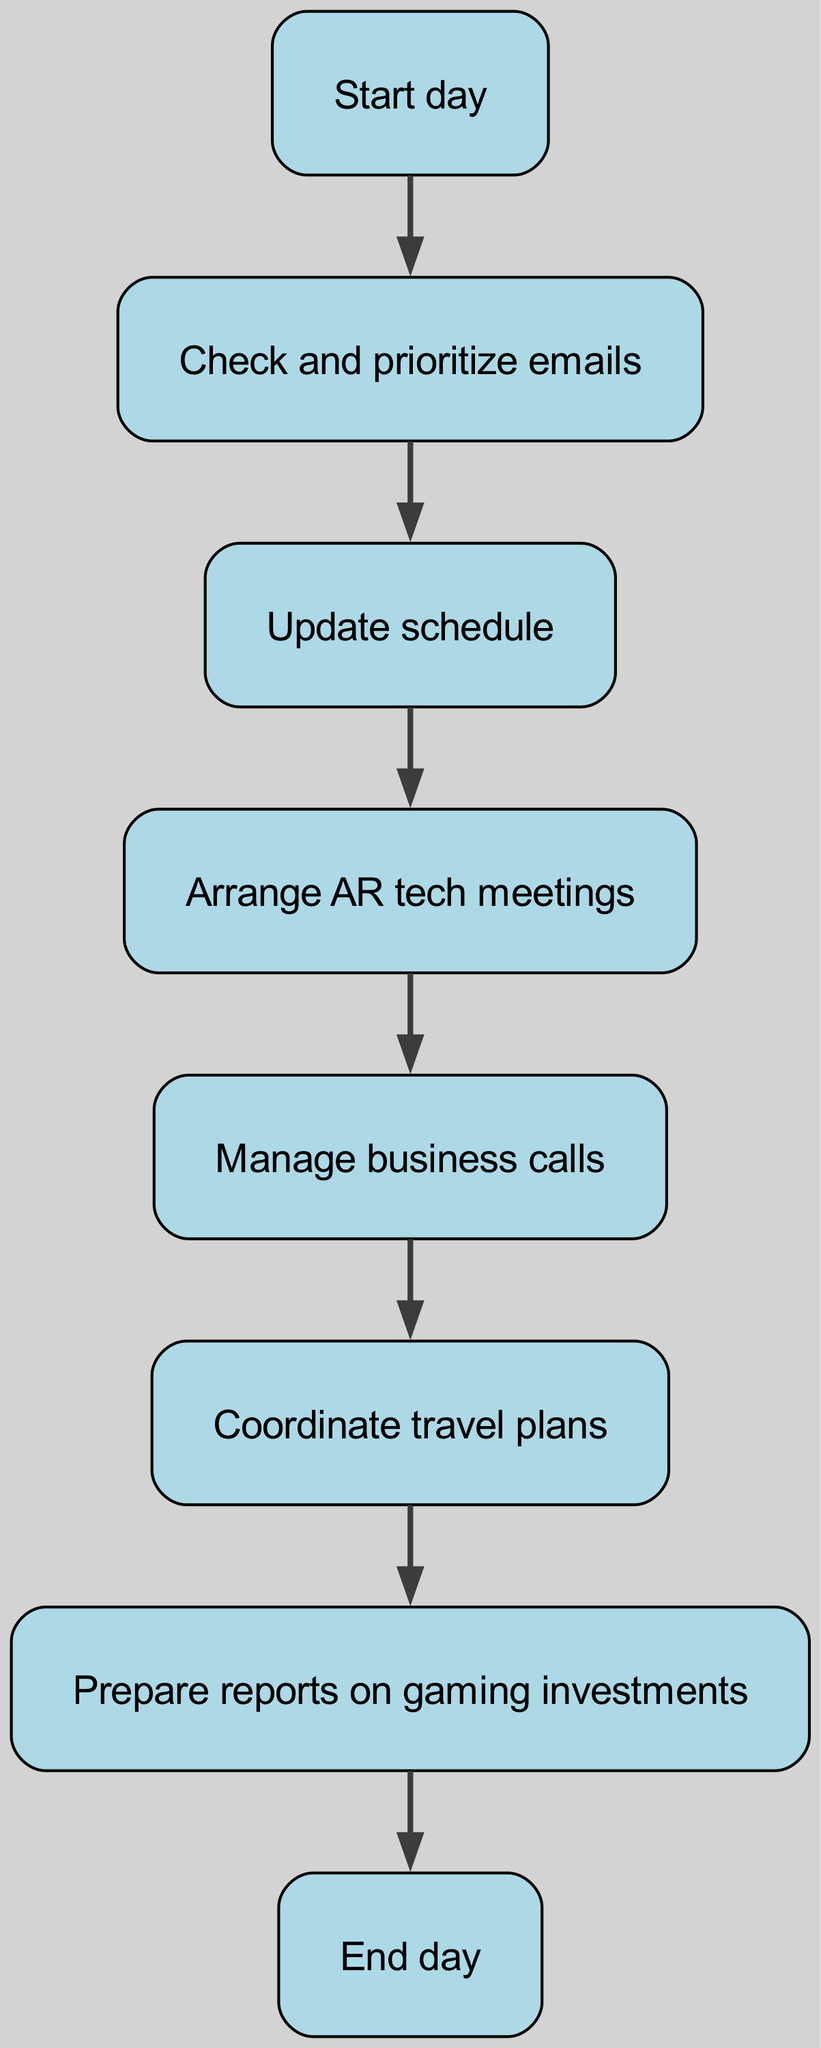What is the starting point of the workflow? The workflow begins at the node labeled "Start day." This is the first node in the diagram that indicates where the daily tasks commence.
Answer: Start day How many nodes are present in the diagram? To find the total number of nodes, we can count each unique node in the diagram. There are eight nodes labeled from "Start day" to "End day."
Answer: Eight What is the last step in the workflow? The workflow ends with the node labeled "End day," which signifies the conclusion of the daily tasks. This node is the last in the flow sequence.
Answer: End day Which task immediately follows checking and prioritizing emails? The task that comes after "Check and prioritize emails" is "Update schedule." This relationship is shown in the flow from node two to node three.
Answer: Update schedule What task is arranged after updating the schedule? After updating the schedule, the next task arranged is "Arrange AR tech meetings." This follows the sequential flow outlined in the diagram.
Answer: Arrange AR tech meetings How does the workflow progress after arranging AR tech meetings? The workflow continues from "Arrange AR tech meetings" to "Manage business calls." This transition is directly indicated in the flow of the diagram.
Answer: Manage business calls What action does the assistant take before preparing reports on gaming investments? Before preparing reports on gaming investments, the assistant coordinates travel plans. This task is reached by following the preceding flow from the node before it.
Answer: Coordinate travel plans What is the relationship between managing business calls and coordinating travel plans? The relationship is sequential, as the assistant first manages business calls, which leads to coordinating travel plans thereafter. This is represented in the diagram from node five to node six.
Answer: Sequential 